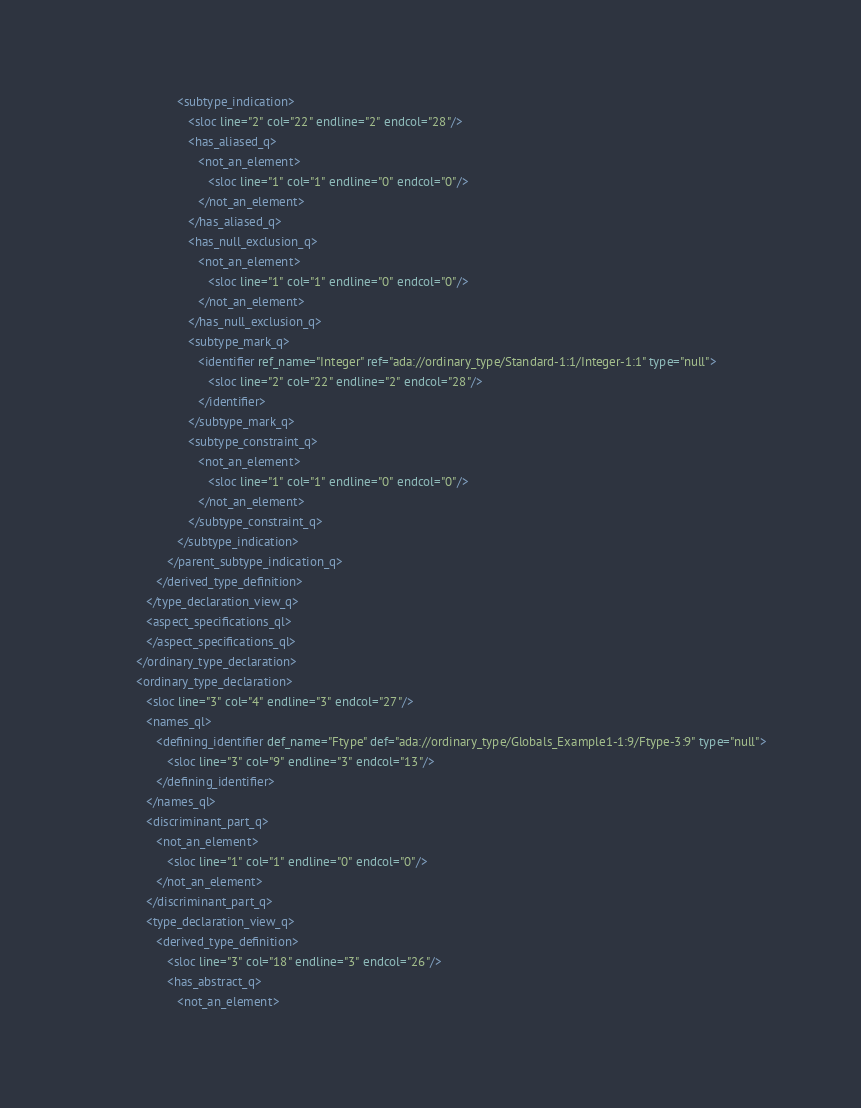Convert code to text. <code><loc_0><loc_0><loc_500><loc_500><_XML_>                        <subtype_indication>
                           <sloc line="2" col="22" endline="2" endcol="28"/>
                           <has_aliased_q>
                              <not_an_element>
                                 <sloc line="1" col="1" endline="0" endcol="0"/>
                              </not_an_element>
                           </has_aliased_q>
                           <has_null_exclusion_q>
                              <not_an_element>
                                 <sloc line="1" col="1" endline="0" endcol="0"/>
                              </not_an_element>
                           </has_null_exclusion_q>
                           <subtype_mark_q>
                              <identifier ref_name="Integer" ref="ada://ordinary_type/Standard-1:1/Integer-1:1" type="null">
                                 <sloc line="2" col="22" endline="2" endcol="28"/>
                              </identifier>
                           </subtype_mark_q>
                           <subtype_constraint_q>
                              <not_an_element>
                                 <sloc line="1" col="1" endline="0" endcol="0"/>
                              </not_an_element>
                           </subtype_constraint_q>
                        </subtype_indication>
                     </parent_subtype_indication_q>
                  </derived_type_definition>
               </type_declaration_view_q>
               <aspect_specifications_ql>
               </aspect_specifications_ql>
            </ordinary_type_declaration>
            <ordinary_type_declaration>
               <sloc line="3" col="4" endline="3" endcol="27"/>
               <names_ql>
                  <defining_identifier def_name="Ftype" def="ada://ordinary_type/Globals_Example1-1:9/Ftype-3:9" type="null">
                     <sloc line="3" col="9" endline="3" endcol="13"/>
                  </defining_identifier>
               </names_ql>
               <discriminant_part_q>
                  <not_an_element>
                     <sloc line="1" col="1" endline="0" endcol="0"/>
                  </not_an_element>
               </discriminant_part_q>
               <type_declaration_view_q>
                  <derived_type_definition>
                     <sloc line="3" col="18" endline="3" endcol="26"/>
                     <has_abstract_q>
                        <not_an_element></code> 